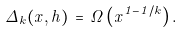<formula> <loc_0><loc_0><loc_500><loc_500>\Delta _ { k } ( x , h ) \, = \, \Omega \left ( x ^ { 1 - 1 / k } \right ) .</formula> 